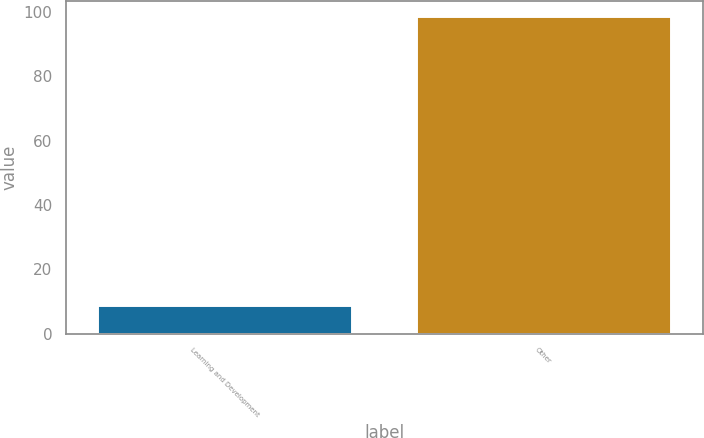<chart> <loc_0><loc_0><loc_500><loc_500><bar_chart><fcel>Learning and Development<fcel>Other<nl><fcel>8.8<fcel>98.6<nl></chart> 